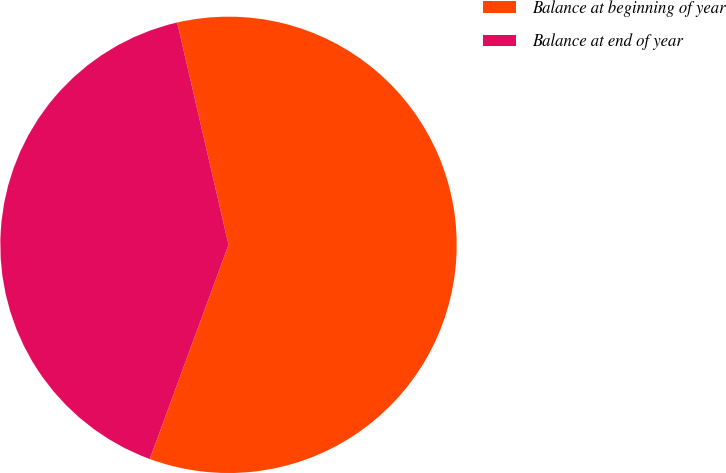Convert chart. <chart><loc_0><loc_0><loc_500><loc_500><pie_chart><fcel>Balance at beginning of year<fcel>Balance at end of year<nl><fcel>59.22%<fcel>40.78%<nl></chart> 